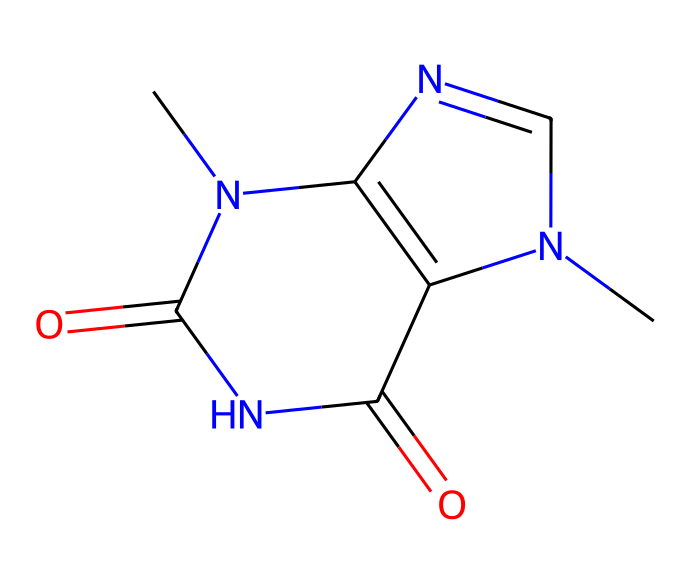What is the molecular formula of theobromine? To determine the molecular formula from the SMILES representation, we can analyze the structure. The representation indicates the presence of carbon (C), hydrogen (H), nitrogen (N), and oxygen (O) atoms. Counting the atoms gives us C7, H8, N4, O2. Therefore, the molecular formula is C7H8N4O2.
Answer: C7H8N4O2 How many nitrogen atoms are present in theobromine? In the SMILES structure, we can visually count the nitrogen atoms represented. There are a total of four nitrogen atoms in the chemical structure of theobromine.
Answer: 4 What functional groups can be identified in theobromine? Examining the structure, we see groups that contribute to its properties. The presence of amine and ketone functional groups is apparent. Therefore, the main functional groups are amine (due to nitrogen atoms) and ketone (with the carbonyl groups).
Answer: amine, ketone What properties might theobromine impart due to its nitrogen content? The nitrogen content in alkaloids like theobromine often leads to physiological effects such as stimulatory actions and potential bitter flavors. Thus, the nitrogen could contribute to these properties.
Answer: stimulant, bitter In what class of chemicals does theobromine belong? The SMILES representation indicates the structure containing nitrogen and carbon, which confirms that theobromine is categorized under alkaloids, known for their distinctive effects and complex structures.
Answer: alkaloids How would the presence of multiple nitrogen atoms affect the pharmacological activity of theobromine? The presence of multiple nitrogen atoms generally enhances the potential for binding to biological receptors, which can increase the pharmacological activity. In the case of theobromine, this may lead to effects such as increased heart rate.
Answer: increased activity 